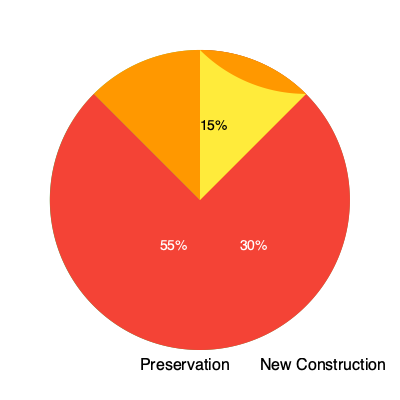As an elected official supporting preservation efforts, analyze the pie charts comparing the carbon footprint of preserving old buildings versus constructing new ones. What conclusion can be drawn about the environmental impact of preservation versus new construction, and how might this inform policy decisions? To analyze the pie charts and draw a conclusion, let's break down the information step-by-step:

1. Preservation pie chart:
   - 70% of the carbon footprint
   - 30% of the carbon footprint
   Total: 100%

2. New Construction pie chart:
   - 55% of the carbon footprint
   - 30% of the carbon footprint
   - 15% of the carbon footprint
   Total: 100%

3. Comparison:
   - Preservation has two categories, while new construction has three.
   - The largest segment in preservation (70%) is greater than the largest in new construction (55%).
   - Both charts have a 30% segment, but they likely represent different aspects of the process.

4. Interpretation:
   - The preservation chart suggests a more streamlined process with fewer major contributors to the carbon footprint.
   - The new construction chart indicates a more complex process with multiple significant sources of carbon emissions.

5. Environmental impact:
   - Preservation appears to have a more concentrated carbon footprint, potentially easier to manage and mitigate.
   - New construction seems to have a more diverse range of carbon sources, which may be more challenging to address comprehensively.

6. Policy implications:
   - Promoting preservation could lead to more predictable and manageable carbon emissions.
   - Policies supporting preservation might be more straightforward to implement and monitor.
   - New construction policies would need to address multiple aspects of the building process to effectively reduce carbon footprint.

Conclusion: Based on the pie charts, preservation of old buildings appears to have a more focused and potentially manageable carbon footprint compared to new construction. This suggests that preservation efforts could be more environmentally friendly and easier to regulate from a policy standpoint.
Answer: Preservation has a more concentrated carbon footprint, potentially easier to manage and regulate than new construction, suggesting it may be more environmentally friendly and simpler to address through policy. 